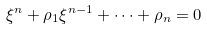Convert formula to latex. <formula><loc_0><loc_0><loc_500><loc_500>\xi ^ { n } + \rho _ { 1 } \xi ^ { n - 1 } + \dots + \rho _ { n } = 0</formula> 